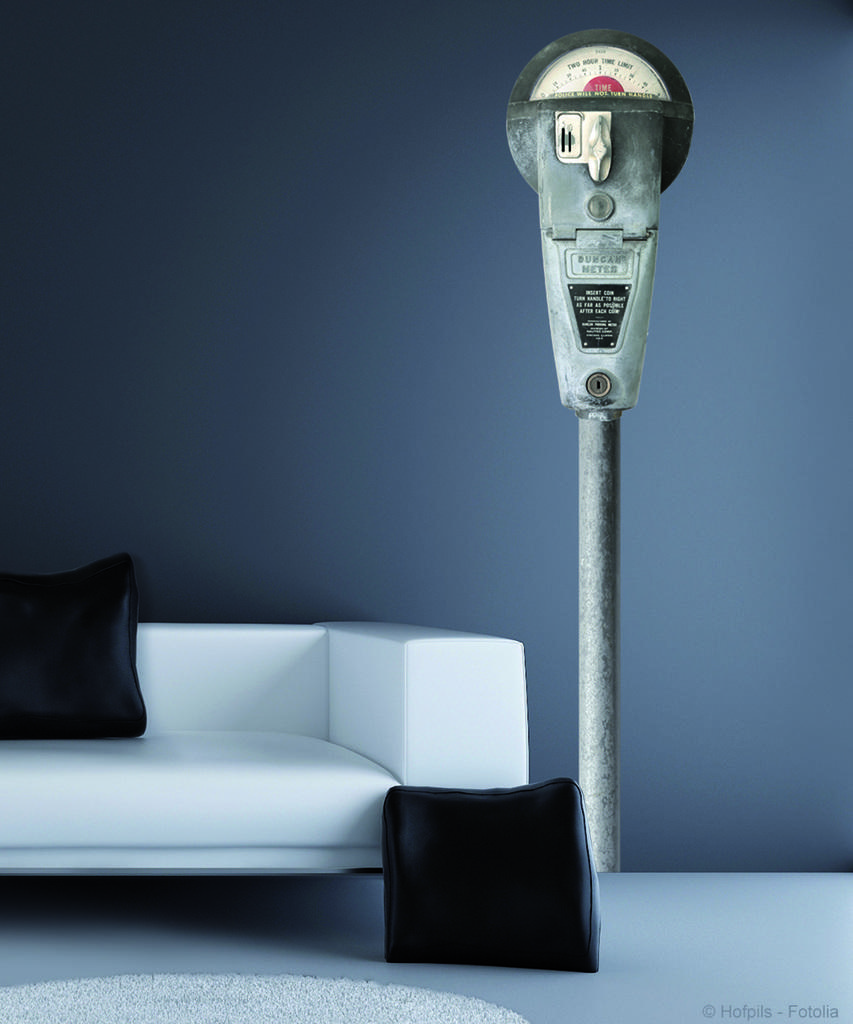How would you summarize this image in a sentence or two? In this image I can see a sofa and two cushions on black color. I can also see a meteor over here. 